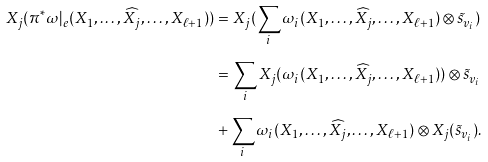Convert formula to latex. <formula><loc_0><loc_0><loc_500><loc_500>X _ { j } ( \pi ^ { * } \omega | _ { e } ( X _ { 1 } , \dots , \widehat { X _ { j } } , \dots , X _ { \ell + 1 } ) ) & = X _ { j } ( \sum _ { i } \omega _ { i } ( X _ { 1 } , \dots , \widehat { X _ { j } } , \dots , X _ { \ell + 1 } ) \otimes \tilde { s } _ { v _ { i } } ) \\ & = \sum _ { i } X _ { j } ( \omega _ { i } ( X _ { 1 } , \dots , \widehat { X _ { j } } , \dots , X _ { \ell + 1 } ) ) \otimes \tilde { s } _ { v _ { i } } \\ & + \sum _ { i } \omega _ { i } ( X _ { 1 } , \dots , \widehat { X _ { j } } , \dots , X _ { \ell + 1 } ) \otimes X _ { j } ( \tilde { s } _ { v _ { i } } ) .</formula> 